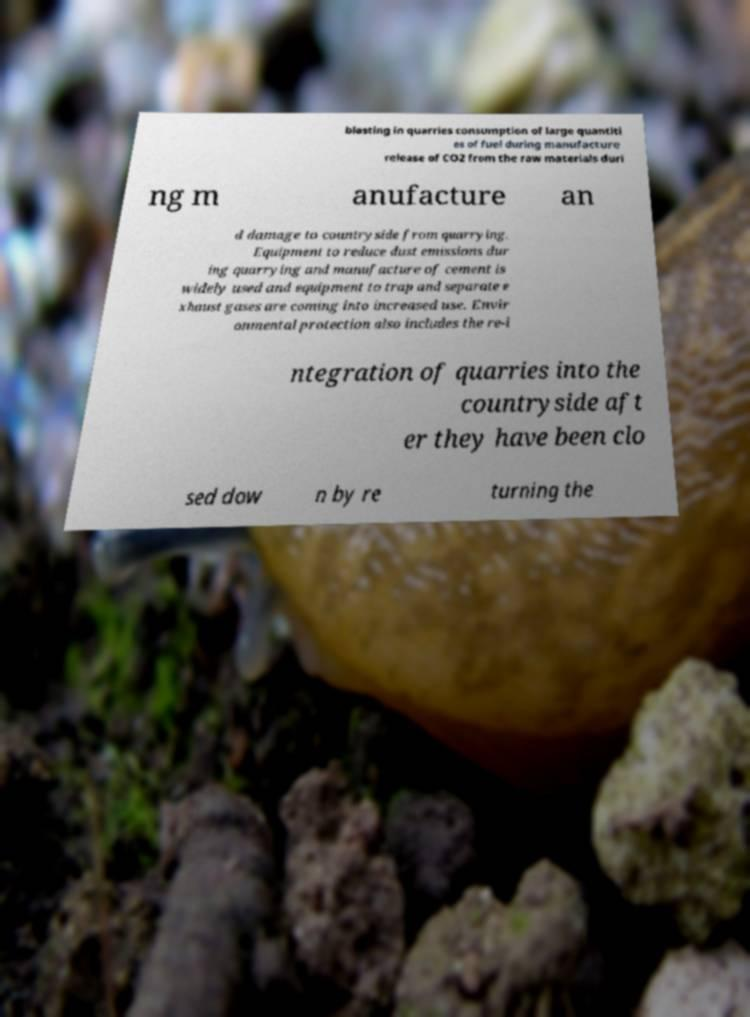Could you extract and type out the text from this image? blasting in quarries consumption of large quantiti es of fuel during manufacture release of CO2 from the raw materials duri ng m anufacture an d damage to countryside from quarrying. Equipment to reduce dust emissions dur ing quarrying and manufacture of cement is widely used and equipment to trap and separate e xhaust gases are coming into increased use. Envir onmental protection also includes the re-i ntegration of quarries into the countryside aft er they have been clo sed dow n by re turning the 